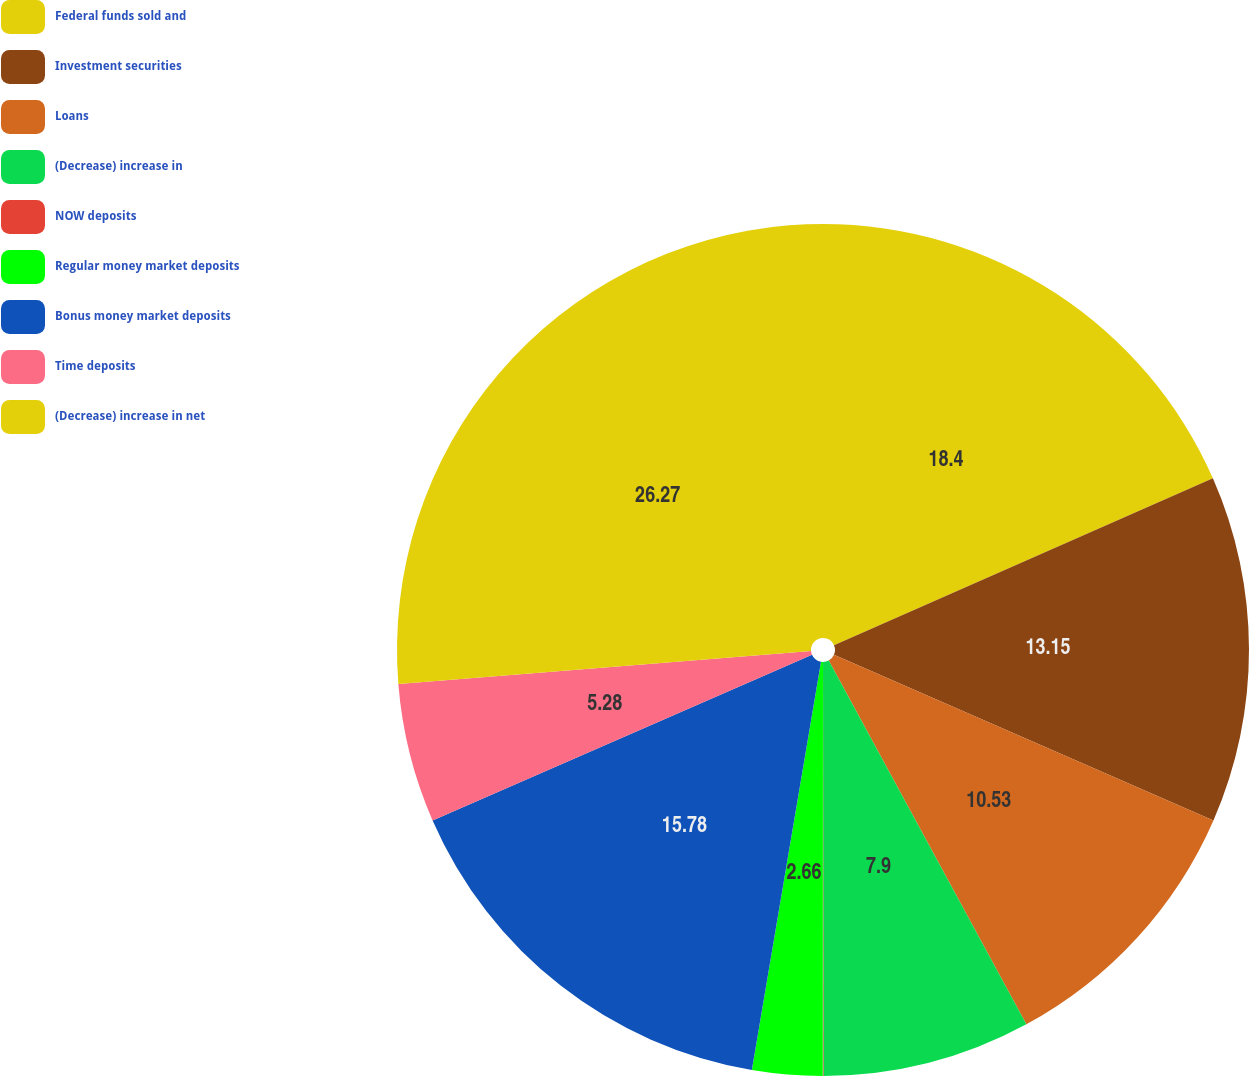Convert chart to OTSL. <chart><loc_0><loc_0><loc_500><loc_500><pie_chart><fcel>Federal funds sold and<fcel>Investment securities<fcel>Loans<fcel>(Decrease) increase in<fcel>NOW deposits<fcel>Regular money market deposits<fcel>Bonus money market deposits<fcel>Time deposits<fcel>(Decrease) increase in net<nl><fcel>18.4%<fcel>13.15%<fcel>10.53%<fcel>7.9%<fcel>0.03%<fcel>2.66%<fcel>15.78%<fcel>5.28%<fcel>26.27%<nl></chart> 